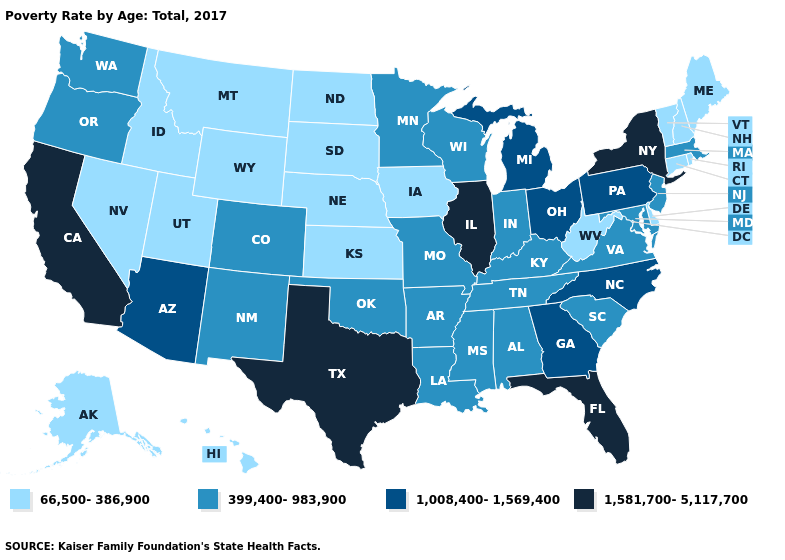Does Pennsylvania have a lower value than Illinois?
Keep it brief. Yes. What is the highest value in states that border Missouri?
Short answer required. 1,581,700-5,117,700. What is the highest value in states that border Wyoming?
Short answer required. 399,400-983,900. Does Rhode Island have the highest value in the USA?
Answer briefly. No. Does the first symbol in the legend represent the smallest category?
Quick response, please. Yes. Does the map have missing data?
Quick response, please. No. Among the states that border Georgia , does North Carolina have the lowest value?
Be succinct. No. What is the value of Oregon?
Short answer required. 399,400-983,900. Does Nevada have a higher value than North Carolina?
Quick response, please. No. What is the highest value in the USA?
Give a very brief answer. 1,581,700-5,117,700. What is the highest value in the USA?
Short answer required. 1,581,700-5,117,700. Does Florida have a higher value than New York?
Give a very brief answer. No. Among the states that border California , which have the highest value?
Keep it brief. Arizona. What is the value of Maine?
Answer briefly. 66,500-386,900. 